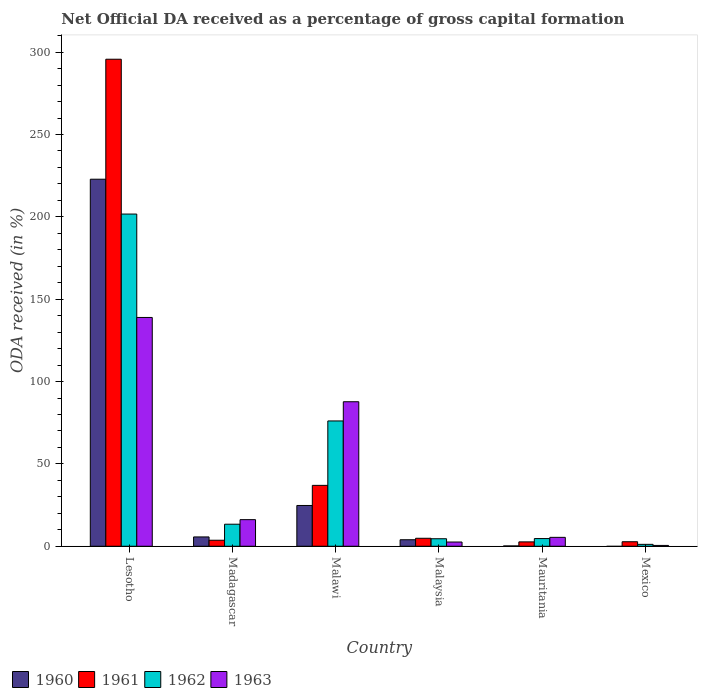How many groups of bars are there?
Ensure brevity in your answer.  6. Are the number of bars on each tick of the X-axis equal?
Your response must be concise. No. How many bars are there on the 3rd tick from the right?
Provide a succinct answer. 4. What is the label of the 2nd group of bars from the left?
Make the answer very short. Madagascar. What is the net ODA received in 1962 in Malawi?
Give a very brief answer. 76.08. Across all countries, what is the maximum net ODA received in 1961?
Ensure brevity in your answer.  295.71. Across all countries, what is the minimum net ODA received in 1961?
Your answer should be compact. 2.65. In which country was the net ODA received in 1960 maximum?
Provide a succinct answer. Lesotho. What is the total net ODA received in 1962 in the graph?
Offer a very short reply. 301.54. What is the difference between the net ODA received in 1963 in Malawi and that in Mauritania?
Offer a terse response. 82.34. What is the difference between the net ODA received in 1963 in Mauritania and the net ODA received in 1961 in Malaysia?
Your answer should be very brief. 0.56. What is the average net ODA received in 1962 per country?
Offer a very short reply. 50.26. What is the difference between the net ODA received of/in 1960 and net ODA received of/in 1962 in Malawi?
Provide a short and direct response. -51.32. What is the ratio of the net ODA received in 1963 in Lesotho to that in Madagascar?
Give a very brief answer. 8.6. Is the net ODA received in 1963 in Malawi less than that in Mauritania?
Keep it short and to the point. No. Is the difference between the net ODA received in 1960 in Madagascar and Mauritania greater than the difference between the net ODA received in 1962 in Madagascar and Mauritania?
Provide a succinct answer. No. What is the difference between the highest and the second highest net ODA received in 1960?
Your response must be concise. 19.11. What is the difference between the highest and the lowest net ODA received in 1963?
Ensure brevity in your answer.  138.41. In how many countries, is the net ODA received in 1963 greater than the average net ODA received in 1963 taken over all countries?
Provide a succinct answer. 2. Is the sum of the net ODA received in 1962 in Malaysia and Mauritania greater than the maximum net ODA received in 1963 across all countries?
Provide a succinct answer. No. Is it the case that in every country, the sum of the net ODA received in 1960 and net ODA received in 1962 is greater than the sum of net ODA received in 1963 and net ODA received in 1961?
Your response must be concise. No. Is it the case that in every country, the sum of the net ODA received in 1960 and net ODA received in 1963 is greater than the net ODA received in 1961?
Give a very brief answer. No. How many bars are there?
Your answer should be compact. 23. What is the difference between two consecutive major ticks on the Y-axis?
Provide a short and direct response. 50. Does the graph contain any zero values?
Keep it short and to the point. Yes. Does the graph contain grids?
Your response must be concise. No. Where does the legend appear in the graph?
Your response must be concise. Bottom left. What is the title of the graph?
Your answer should be very brief. Net Official DA received as a percentage of gross capital formation. What is the label or title of the Y-axis?
Your response must be concise. ODA received (in %). What is the ODA received (in %) in 1960 in Lesotho?
Ensure brevity in your answer.  222.86. What is the ODA received (in %) in 1961 in Lesotho?
Ensure brevity in your answer.  295.71. What is the ODA received (in %) in 1962 in Lesotho?
Offer a terse response. 201.7. What is the ODA received (in %) of 1963 in Lesotho?
Ensure brevity in your answer.  138.92. What is the ODA received (in %) of 1960 in Madagascar?
Your answer should be very brief. 5.66. What is the ODA received (in %) in 1961 in Madagascar?
Your answer should be very brief. 3.65. What is the ODA received (in %) in 1962 in Madagascar?
Give a very brief answer. 13.38. What is the ODA received (in %) in 1963 in Madagascar?
Give a very brief answer. 16.15. What is the ODA received (in %) of 1960 in Malawi?
Provide a succinct answer. 24.76. What is the ODA received (in %) of 1961 in Malawi?
Offer a very short reply. 36.97. What is the ODA received (in %) of 1962 in Malawi?
Your response must be concise. 76.08. What is the ODA received (in %) of 1963 in Malawi?
Offer a terse response. 87.74. What is the ODA received (in %) in 1960 in Malaysia?
Your answer should be very brief. 3.95. What is the ODA received (in %) in 1961 in Malaysia?
Make the answer very short. 4.84. What is the ODA received (in %) in 1962 in Malaysia?
Provide a succinct answer. 4.56. What is the ODA received (in %) of 1963 in Malaysia?
Your answer should be compact. 2.57. What is the ODA received (in %) in 1960 in Mauritania?
Provide a succinct answer. 0.19. What is the ODA received (in %) in 1961 in Mauritania?
Your response must be concise. 2.65. What is the ODA received (in %) of 1962 in Mauritania?
Your answer should be compact. 4.66. What is the ODA received (in %) of 1963 in Mauritania?
Offer a terse response. 5.4. What is the ODA received (in %) of 1961 in Mexico?
Give a very brief answer. 2.74. What is the ODA received (in %) in 1962 in Mexico?
Give a very brief answer. 1.16. What is the ODA received (in %) in 1963 in Mexico?
Make the answer very short. 0.5. Across all countries, what is the maximum ODA received (in %) of 1960?
Make the answer very short. 222.86. Across all countries, what is the maximum ODA received (in %) of 1961?
Ensure brevity in your answer.  295.71. Across all countries, what is the maximum ODA received (in %) in 1962?
Make the answer very short. 201.7. Across all countries, what is the maximum ODA received (in %) of 1963?
Provide a short and direct response. 138.92. Across all countries, what is the minimum ODA received (in %) of 1960?
Your response must be concise. 0. Across all countries, what is the minimum ODA received (in %) of 1961?
Your response must be concise. 2.65. Across all countries, what is the minimum ODA received (in %) in 1962?
Make the answer very short. 1.16. Across all countries, what is the minimum ODA received (in %) of 1963?
Your answer should be very brief. 0.5. What is the total ODA received (in %) of 1960 in the graph?
Give a very brief answer. 257.42. What is the total ODA received (in %) in 1961 in the graph?
Provide a short and direct response. 346.57. What is the total ODA received (in %) in 1962 in the graph?
Ensure brevity in your answer.  301.54. What is the total ODA received (in %) of 1963 in the graph?
Give a very brief answer. 251.28. What is the difference between the ODA received (in %) in 1960 in Lesotho and that in Madagascar?
Your response must be concise. 217.2. What is the difference between the ODA received (in %) of 1961 in Lesotho and that in Madagascar?
Your response must be concise. 292.06. What is the difference between the ODA received (in %) of 1962 in Lesotho and that in Madagascar?
Ensure brevity in your answer.  188.32. What is the difference between the ODA received (in %) in 1963 in Lesotho and that in Madagascar?
Provide a short and direct response. 122.76. What is the difference between the ODA received (in %) of 1960 in Lesotho and that in Malawi?
Keep it short and to the point. 198.1. What is the difference between the ODA received (in %) of 1961 in Lesotho and that in Malawi?
Make the answer very short. 258.74. What is the difference between the ODA received (in %) of 1962 in Lesotho and that in Malawi?
Your answer should be very brief. 125.62. What is the difference between the ODA received (in %) in 1963 in Lesotho and that in Malawi?
Give a very brief answer. 51.18. What is the difference between the ODA received (in %) of 1960 in Lesotho and that in Malaysia?
Offer a terse response. 218.91. What is the difference between the ODA received (in %) of 1961 in Lesotho and that in Malaysia?
Your response must be concise. 290.87. What is the difference between the ODA received (in %) in 1962 in Lesotho and that in Malaysia?
Keep it short and to the point. 197.14. What is the difference between the ODA received (in %) in 1963 in Lesotho and that in Malaysia?
Provide a short and direct response. 136.35. What is the difference between the ODA received (in %) of 1960 in Lesotho and that in Mauritania?
Your answer should be very brief. 222.67. What is the difference between the ODA received (in %) of 1961 in Lesotho and that in Mauritania?
Your answer should be compact. 293.07. What is the difference between the ODA received (in %) of 1962 in Lesotho and that in Mauritania?
Make the answer very short. 197.04. What is the difference between the ODA received (in %) of 1963 in Lesotho and that in Mauritania?
Your answer should be very brief. 133.51. What is the difference between the ODA received (in %) of 1961 in Lesotho and that in Mexico?
Your response must be concise. 292.98. What is the difference between the ODA received (in %) of 1962 in Lesotho and that in Mexico?
Your answer should be compact. 200.54. What is the difference between the ODA received (in %) in 1963 in Lesotho and that in Mexico?
Ensure brevity in your answer.  138.41. What is the difference between the ODA received (in %) in 1960 in Madagascar and that in Malawi?
Your answer should be compact. -19.11. What is the difference between the ODA received (in %) of 1961 in Madagascar and that in Malawi?
Keep it short and to the point. -33.32. What is the difference between the ODA received (in %) in 1962 in Madagascar and that in Malawi?
Give a very brief answer. -62.7. What is the difference between the ODA received (in %) in 1963 in Madagascar and that in Malawi?
Keep it short and to the point. -71.59. What is the difference between the ODA received (in %) of 1960 in Madagascar and that in Malaysia?
Your answer should be compact. 1.7. What is the difference between the ODA received (in %) in 1961 in Madagascar and that in Malaysia?
Your response must be concise. -1.19. What is the difference between the ODA received (in %) of 1962 in Madagascar and that in Malaysia?
Your answer should be compact. 8.82. What is the difference between the ODA received (in %) in 1963 in Madagascar and that in Malaysia?
Your answer should be compact. 13.59. What is the difference between the ODA received (in %) of 1960 in Madagascar and that in Mauritania?
Your answer should be very brief. 5.46. What is the difference between the ODA received (in %) of 1962 in Madagascar and that in Mauritania?
Provide a short and direct response. 8.72. What is the difference between the ODA received (in %) of 1963 in Madagascar and that in Mauritania?
Give a very brief answer. 10.75. What is the difference between the ODA received (in %) in 1962 in Madagascar and that in Mexico?
Keep it short and to the point. 12.22. What is the difference between the ODA received (in %) of 1963 in Madagascar and that in Mexico?
Keep it short and to the point. 15.65. What is the difference between the ODA received (in %) of 1960 in Malawi and that in Malaysia?
Your answer should be compact. 20.81. What is the difference between the ODA received (in %) of 1961 in Malawi and that in Malaysia?
Provide a short and direct response. 32.13. What is the difference between the ODA received (in %) in 1962 in Malawi and that in Malaysia?
Your answer should be very brief. 71.52. What is the difference between the ODA received (in %) of 1963 in Malawi and that in Malaysia?
Your answer should be compact. 85.17. What is the difference between the ODA received (in %) in 1960 in Malawi and that in Mauritania?
Your answer should be compact. 24.57. What is the difference between the ODA received (in %) in 1961 in Malawi and that in Mauritania?
Make the answer very short. 34.32. What is the difference between the ODA received (in %) in 1962 in Malawi and that in Mauritania?
Your response must be concise. 71.42. What is the difference between the ODA received (in %) of 1963 in Malawi and that in Mauritania?
Provide a succinct answer. 82.34. What is the difference between the ODA received (in %) of 1961 in Malawi and that in Mexico?
Provide a succinct answer. 34.23. What is the difference between the ODA received (in %) in 1962 in Malawi and that in Mexico?
Your answer should be compact. 74.92. What is the difference between the ODA received (in %) of 1963 in Malawi and that in Mexico?
Your answer should be compact. 87.24. What is the difference between the ODA received (in %) of 1960 in Malaysia and that in Mauritania?
Make the answer very short. 3.76. What is the difference between the ODA received (in %) of 1961 in Malaysia and that in Mauritania?
Make the answer very short. 2.2. What is the difference between the ODA received (in %) in 1962 in Malaysia and that in Mauritania?
Ensure brevity in your answer.  -0.1. What is the difference between the ODA received (in %) of 1963 in Malaysia and that in Mauritania?
Offer a very short reply. -2.83. What is the difference between the ODA received (in %) of 1961 in Malaysia and that in Mexico?
Provide a succinct answer. 2.11. What is the difference between the ODA received (in %) of 1962 in Malaysia and that in Mexico?
Offer a terse response. 3.4. What is the difference between the ODA received (in %) of 1963 in Malaysia and that in Mexico?
Offer a very short reply. 2.07. What is the difference between the ODA received (in %) in 1961 in Mauritania and that in Mexico?
Keep it short and to the point. -0.09. What is the difference between the ODA received (in %) of 1962 in Mauritania and that in Mexico?
Your response must be concise. 3.51. What is the difference between the ODA received (in %) of 1963 in Mauritania and that in Mexico?
Offer a terse response. 4.9. What is the difference between the ODA received (in %) in 1960 in Lesotho and the ODA received (in %) in 1961 in Madagascar?
Ensure brevity in your answer.  219.21. What is the difference between the ODA received (in %) in 1960 in Lesotho and the ODA received (in %) in 1962 in Madagascar?
Keep it short and to the point. 209.48. What is the difference between the ODA received (in %) in 1960 in Lesotho and the ODA received (in %) in 1963 in Madagascar?
Offer a very short reply. 206.7. What is the difference between the ODA received (in %) in 1961 in Lesotho and the ODA received (in %) in 1962 in Madagascar?
Your answer should be compact. 282.33. What is the difference between the ODA received (in %) in 1961 in Lesotho and the ODA received (in %) in 1963 in Madagascar?
Your answer should be very brief. 279.56. What is the difference between the ODA received (in %) of 1962 in Lesotho and the ODA received (in %) of 1963 in Madagascar?
Give a very brief answer. 185.55. What is the difference between the ODA received (in %) in 1960 in Lesotho and the ODA received (in %) in 1961 in Malawi?
Provide a short and direct response. 185.89. What is the difference between the ODA received (in %) of 1960 in Lesotho and the ODA received (in %) of 1962 in Malawi?
Make the answer very short. 146.78. What is the difference between the ODA received (in %) of 1960 in Lesotho and the ODA received (in %) of 1963 in Malawi?
Ensure brevity in your answer.  135.12. What is the difference between the ODA received (in %) of 1961 in Lesotho and the ODA received (in %) of 1962 in Malawi?
Give a very brief answer. 219.63. What is the difference between the ODA received (in %) of 1961 in Lesotho and the ODA received (in %) of 1963 in Malawi?
Your answer should be compact. 207.97. What is the difference between the ODA received (in %) of 1962 in Lesotho and the ODA received (in %) of 1963 in Malawi?
Ensure brevity in your answer.  113.96. What is the difference between the ODA received (in %) of 1960 in Lesotho and the ODA received (in %) of 1961 in Malaysia?
Provide a short and direct response. 218.01. What is the difference between the ODA received (in %) of 1960 in Lesotho and the ODA received (in %) of 1962 in Malaysia?
Ensure brevity in your answer.  218.3. What is the difference between the ODA received (in %) in 1960 in Lesotho and the ODA received (in %) in 1963 in Malaysia?
Provide a succinct answer. 220.29. What is the difference between the ODA received (in %) of 1961 in Lesotho and the ODA received (in %) of 1962 in Malaysia?
Offer a terse response. 291.15. What is the difference between the ODA received (in %) in 1961 in Lesotho and the ODA received (in %) in 1963 in Malaysia?
Your answer should be very brief. 293.15. What is the difference between the ODA received (in %) of 1962 in Lesotho and the ODA received (in %) of 1963 in Malaysia?
Provide a short and direct response. 199.13. What is the difference between the ODA received (in %) of 1960 in Lesotho and the ODA received (in %) of 1961 in Mauritania?
Provide a succinct answer. 220.21. What is the difference between the ODA received (in %) in 1960 in Lesotho and the ODA received (in %) in 1962 in Mauritania?
Provide a short and direct response. 218.19. What is the difference between the ODA received (in %) in 1960 in Lesotho and the ODA received (in %) in 1963 in Mauritania?
Your answer should be very brief. 217.45. What is the difference between the ODA received (in %) of 1961 in Lesotho and the ODA received (in %) of 1962 in Mauritania?
Give a very brief answer. 291.05. What is the difference between the ODA received (in %) of 1961 in Lesotho and the ODA received (in %) of 1963 in Mauritania?
Ensure brevity in your answer.  290.31. What is the difference between the ODA received (in %) in 1962 in Lesotho and the ODA received (in %) in 1963 in Mauritania?
Provide a succinct answer. 196.3. What is the difference between the ODA received (in %) in 1960 in Lesotho and the ODA received (in %) in 1961 in Mexico?
Your response must be concise. 220.12. What is the difference between the ODA received (in %) in 1960 in Lesotho and the ODA received (in %) in 1962 in Mexico?
Your answer should be compact. 221.7. What is the difference between the ODA received (in %) of 1960 in Lesotho and the ODA received (in %) of 1963 in Mexico?
Make the answer very short. 222.36. What is the difference between the ODA received (in %) in 1961 in Lesotho and the ODA received (in %) in 1962 in Mexico?
Keep it short and to the point. 294.56. What is the difference between the ODA received (in %) in 1961 in Lesotho and the ODA received (in %) in 1963 in Mexico?
Give a very brief answer. 295.21. What is the difference between the ODA received (in %) of 1962 in Lesotho and the ODA received (in %) of 1963 in Mexico?
Ensure brevity in your answer.  201.2. What is the difference between the ODA received (in %) of 1960 in Madagascar and the ODA received (in %) of 1961 in Malawi?
Keep it short and to the point. -31.32. What is the difference between the ODA received (in %) in 1960 in Madagascar and the ODA received (in %) in 1962 in Malawi?
Provide a short and direct response. -70.43. What is the difference between the ODA received (in %) of 1960 in Madagascar and the ODA received (in %) of 1963 in Malawi?
Your answer should be compact. -82.08. What is the difference between the ODA received (in %) of 1961 in Madagascar and the ODA received (in %) of 1962 in Malawi?
Give a very brief answer. -72.43. What is the difference between the ODA received (in %) of 1961 in Madagascar and the ODA received (in %) of 1963 in Malawi?
Keep it short and to the point. -84.09. What is the difference between the ODA received (in %) of 1962 in Madagascar and the ODA received (in %) of 1963 in Malawi?
Your response must be concise. -74.36. What is the difference between the ODA received (in %) in 1960 in Madagascar and the ODA received (in %) in 1961 in Malaysia?
Offer a terse response. 0.81. What is the difference between the ODA received (in %) in 1960 in Madagascar and the ODA received (in %) in 1962 in Malaysia?
Provide a succinct answer. 1.09. What is the difference between the ODA received (in %) in 1960 in Madagascar and the ODA received (in %) in 1963 in Malaysia?
Keep it short and to the point. 3.09. What is the difference between the ODA received (in %) of 1961 in Madagascar and the ODA received (in %) of 1962 in Malaysia?
Ensure brevity in your answer.  -0.91. What is the difference between the ODA received (in %) of 1961 in Madagascar and the ODA received (in %) of 1963 in Malaysia?
Provide a short and direct response. 1.08. What is the difference between the ODA received (in %) of 1962 in Madagascar and the ODA received (in %) of 1963 in Malaysia?
Offer a terse response. 10.81. What is the difference between the ODA received (in %) in 1960 in Madagascar and the ODA received (in %) in 1961 in Mauritania?
Give a very brief answer. 3.01. What is the difference between the ODA received (in %) of 1960 in Madagascar and the ODA received (in %) of 1962 in Mauritania?
Offer a terse response. 0.99. What is the difference between the ODA received (in %) in 1960 in Madagascar and the ODA received (in %) in 1963 in Mauritania?
Ensure brevity in your answer.  0.25. What is the difference between the ODA received (in %) of 1961 in Madagascar and the ODA received (in %) of 1962 in Mauritania?
Offer a terse response. -1.01. What is the difference between the ODA received (in %) of 1961 in Madagascar and the ODA received (in %) of 1963 in Mauritania?
Your response must be concise. -1.75. What is the difference between the ODA received (in %) of 1962 in Madagascar and the ODA received (in %) of 1963 in Mauritania?
Offer a terse response. 7.98. What is the difference between the ODA received (in %) of 1960 in Madagascar and the ODA received (in %) of 1961 in Mexico?
Provide a short and direct response. 2.92. What is the difference between the ODA received (in %) in 1960 in Madagascar and the ODA received (in %) in 1962 in Mexico?
Provide a short and direct response. 4.5. What is the difference between the ODA received (in %) of 1960 in Madagascar and the ODA received (in %) of 1963 in Mexico?
Offer a terse response. 5.15. What is the difference between the ODA received (in %) in 1961 in Madagascar and the ODA received (in %) in 1962 in Mexico?
Offer a terse response. 2.49. What is the difference between the ODA received (in %) of 1961 in Madagascar and the ODA received (in %) of 1963 in Mexico?
Your response must be concise. 3.15. What is the difference between the ODA received (in %) of 1962 in Madagascar and the ODA received (in %) of 1963 in Mexico?
Make the answer very short. 12.88. What is the difference between the ODA received (in %) in 1960 in Malawi and the ODA received (in %) in 1961 in Malaysia?
Your answer should be very brief. 19.92. What is the difference between the ODA received (in %) in 1960 in Malawi and the ODA received (in %) in 1962 in Malaysia?
Make the answer very short. 20.2. What is the difference between the ODA received (in %) of 1960 in Malawi and the ODA received (in %) of 1963 in Malaysia?
Your response must be concise. 22.19. What is the difference between the ODA received (in %) of 1961 in Malawi and the ODA received (in %) of 1962 in Malaysia?
Keep it short and to the point. 32.41. What is the difference between the ODA received (in %) of 1961 in Malawi and the ODA received (in %) of 1963 in Malaysia?
Make the answer very short. 34.4. What is the difference between the ODA received (in %) in 1962 in Malawi and the ODA received (in %) in 1963 in Malaysia?
Provide a short and direct response. 73.51. What is the difference between the ODA received (in %) of 1960 in Malawi and the ODA received (in %) of 1961 in Mauritania?
Make the answer very short. 22.11. What is the difference between the ODA received (in %) of 1960 in Malawi and the ODA received (in %) of 1962 in Mauritania?
Provide a succinct answer. 20.1. What is the difference between the ODA received (in %) in 1960 in Malawi and the ODA received (in %) in 1963 in Mauritania?
Offer a very short reply. 19.36. What is the difference between the ODA received (in %) of 1961 in Malawi and the ODA received (in %) of 1962 in Mauritania?
Provide a short and direct response. 32.31. What is the difference between the ODA received (in %) in 1961 in Malawi and the ODA received (in %) in 1963 in Mauritania?
Your response must be concise. 31.57. What is the difference between the ODA received (in %) of 1962 in Malawi and the ODA received (in %) of 1963 in Mauritania?
Ensure brevity in your answer.  70.68. What is the difference between the ODA received (in %) of 1960 in Malawi and the ODA received (in %) of 1961 in Mexico?
Offer a very short reply. 22.02. What is the difference between the ODA received (in %) of 1960 in Malawi and the ODA received (in %) of 1962 in Mexico?
Provide a succinct answer. 23.6. What is the difference between the ODA received (in %) of 1960 in Malawi and the ODA received (in %) of 1963 in Mexico?
Offer a terse response. 24.26. What is the difference between the ODA received (in %) in 1961 in Malawi and the ODA received (in %) in 1962 in Mexico?
Make the answer very short. 35.82. What is the difference between the ODA received (in %) in 1961 in Malawi and the ODA received (in %) in 1963 in Mexico?
Offer a very short reply. 36.47. What is the difference between the ODA received (in %) of 1962 in Malawi and the ODA received (in %) of 1963 in Mexico?
Your answer should be compact. 75.58. What is the difference between the ODA received (in %) in 1960 in Malaysia and the ODA received (in %) in 1961 in Mauritania?
Your answer should be compact. 1.3. What is the difference between the ODA received (in %) of 1960 in Malaysia and the ODA received (in %) of 1962 in Mauritania?
Offer a very short reply. -0.71. What is the difference between the ODA received (in %) in 1960 in Malaysia and the ODA received (in %) in 1963 in Mauritania?
Your response must be concise. -1.45. What is the difference between the ODA received (in %) of 1961 in Malaysia and the ODA received (in %) of 1962 in Mauritania?
Your answer should be compact. 0.18. What is the difference between the ODA received (in %) in 1961 in Malaysia and the ODA received (in %) in 1963 in Mauritania?
Keep it short and to the point. -0.56. What is the difference between the ODA received (in %) of 1962 in Malaysia and the ODA received (in %) of 1963 in Mauritania?
Offer a very short reply. -0.84. What is the difference between the ODA received (in %) of 1960 in Malaysia and the ODA received (in %) of 1961 in Mexico?
Ensure brevity in your answer.  1.21. What is the difference between the ODA received (in %) in 1960 in Malaysia and the ODA received (in %) in 1962 in Mexico?
Make the answer very short. 2.79. What is the difference between the ODA received (in %) in 1960 in Malaysia and the ODA received (in %) in 1963 in Mexico?
Make the answer very short. 3.45. What is the difference between the ODA received (in %) in 1961 in Malaysia and the ODA received (in %) in 1962 in Mexico?
Provide a short and direct response. 3.69. What is the difference between the ODA received (in %) of 1961 in Malaysia and the ODA received (in %) of 1963 in Mexico?
Provide a succinct answer. 4.34. What is the difference between the ODA received (in %) of 1962 in Malaysia and the ODA received (in %) of 1963 in Mexico?
Your response must be concise. 4.06. What is the difference between the ODA received (in %) in 1960 in Mauritania and the ODA received (in %) in 1961 in Mexico?
Ensure brevity in your answer.  -2.55. What is the difference between the ODA received (in %) in 1960 in Mauritania and the ODA received (in %) in 1962 in Mexico?
Give a very brief answer. -0.97. What is the difference between the ODA received (in %) in 1960 in Mauritania and the ODA received (in %) in 1963 in Mexico?
Your response must be concise. -0.31. What is the difference between the ODA received (in %) in 1961 in Mauritania and the ODA received (in %) in 1962 in Mexico?
Give a very brief answer. 1.49. What is the difference between the ODA received (in %) in 1961 in Mauritania and the ODA received (in %) in 1963 in Mexico?
Ensure brevity in your answer.  2.15. What is the difference between the ODA received (in %) of 1962 in Mauritania and the ODA received (in %) of 1963 in Mexico?
Offer a terse response. 4.16. What is the average ODA received (in %) in 1960 per country?
Make the answer very short. 42.9. What is the average ODA received (in %) of 1961 per country?
Offer a terse response. 57.76. What is the average ODA received (in %) in 1962 per country?
Your response must be concise. 50.26. What is the average ODA received (in %) in 1963 per country?
Provide a short and direct response. 41.88. What is the difference between the ODA received (in %) of 1960 and ODA received (in %) of 1961 in Lesotho?
Your answer should be compact. -72.86. What is the difference between the ODA received (in %) of 1960 and ODA received (in %) of 1962 in Lesotho?
Your response must be concise. 21.16. What is the difference between the ODA received (in %) in 1960 and ODA received (in %) in 1963 in Lesotho?
Make the answer very short. 83.94. What is the difference between the ODA received (in %) of 1961 and ODA received (in %) of 1962 in Lesotho?
Your answer should be compact. 94.01. What is the difference between the ODA received (in %) in 1961 and ODA received (in %) in 1963 in Lesotho?
Keep it short and to the point. 156.8. What is the difference between the ODA received (in %) of 1962 and ODA received (in %) of 1963 in Lesotho?
Give a very brief answer. 62.78. What is the difference between the ODA received (in %) of 1960 and ODA received (in %) of 1961 in Madagascar?
Make the answer very short. 2. What is the difference between the ODA received (in %) in 1960 and ODA received (in %) in 1962 in Madagascar?
Your answer should be compact. -7.72. What is the difference between the ODA received (in %) in 1960 and ODA received (in %) in 1963 in Madagascar?
Ensure brevity in your answer.  -10.5. What is the difference between the ODA received (in %) in 1961 and ODA received (in %) in 1962 in Madagascar?
Provide a succinct answer. -9.73. What is the difference between the ODA received (in %) of 1961 and ODA received (in %) of 1963 in Madagascar?
Provide a succinct answer. -12.5. What is the difference between the ODA received (in %) of 1962 and ODA received (in %) of 1963 in Madagascar?
Ensure brevity in your answer.  -2.77. What is the difference between the ODA received (in %) in 1960 and ODA received (in %) in 1961 in Malawi?
Provide a succinct answer. -12.21. What is the difference between the ODA received (in %) of 1960 and ODA received (in %) of 1962 in Malawi?
Make the answer very short. -51.32. What is the difference between the ODA received (in %) in 1960 and ODA received (in %) in 1963 in Malawi?
Your response must be concise. -62.98. What is the difference between the ODA received (in %) of 1961 and ODA received (in %) of 1962 in Malawi?
Provide a short and direct response. -39.11. What is the difference between the ODA received (in %) of 1961 and ODA received (in %) of 1963 in Malawi?
Offer a terse response. -50.77. What is the difference between the ODA received (in %) of 1962 and ODA received (in %) of 1963 in Malawi?
Provide a short and direct response. -11.66. What is the difference between the ODA received (in %) of 1960 and ODA received (in %) of 1961 in Malaysia?
Keep it short and to the point. -0.89. What is the difference between the ODA received (in %) of 1960 and ODA received (in %) of 1962 in Malaysia?
Offer a terse response. -0.61. What is the difference between the ODA received (in %) in 1960 and ODA received (in %) in 1963 in Malaysia?
Your answer should be very brief. 1.38. What is the difference between the ODA received (in %) of 1961 and ODA received (in %) of 1962 in Malaysia?
Offer a terse response. 0.28. What is the difference between the ODA received (in %) in 1961 and ODA received (in %) in 1963 in Malaysia?
Ensure brevity in your answer.  2.28. What is the difference between the ODA received (in %) in 1962 and ODA received (in %) in 1963 in Malaysia?
Make the answer very short. 1.99. What is the difference between the ODA received (in %) in 1960 and ODA received (in %) in 1961 in Mauritania?
Give a very brief answer. -2.46. What is the difference between the ODA received (in %) in 1960 and ODA received (in %) in 1962 in Mauritania?
Provide a succinct answer. -4.47. What is the difference between the ODA received (in %) of 1960 and ODA received (in %) of 1963 in Mauritania?
Give a very brief answer. -5.21. What is the difference between the ODA received (in %) of 1961 and ODA received (in %) of 1962 in Mauritania?
Make the answer very short. -2.02. What is the difference between the ODA received (in %) in 1961 and ODA received (in %) in 1963 in Mauritania?
Your response must be concise. -2.75. What is the difference between the ODA received (in %) in 1962 and ODA received (in %) in 1963 in Mauritania?
Provide a succinct answer. -0.74. What is the difference between the ODA received (in %) of 1961 and ODA received (in %) of 1962 in Mexico?
Your response must be concise. 1.58. What is the difference between the ODA received (in %) in 1961 and ODA received (in %) in 1963 in Mexico?
Provide a short and direct response. 2.24. What is the difference between the ODA received (in %) of 1962 and ODA received (in %) of 1963 in Mexico?
Give a very brief answer. 0.66. What is the ratio of the ODA received (in %) of 1960 in Lesotho to that in Madagascar?
Offer a terse response. 39.4. What is the ratio of the ODA received (in %) of 1961 in Lesotho to that in Madagascar?
Ensure brevity in your answer.  80.97. What is the ratio of the ODA received (in %) in 1962 in Lesotho to that in Madagascar?
Make the answer very short. 15.07. What is the ratio of the ODA received (in %) of 1963 in Lesotho to that in Madagascar?
Give a very brief answer. 8.6. What is the ratio of the ODA received (in %) in 1960 in Lesotho to that in Malawi?
Provide a succinct answer. 9. What is the ratio of the ODA received (in %) of 1961 in Lesotho to that in Malawi?
Keep it short and to the point. 8. What is the ratio of the ODA received (in %) of 1962 in Lesotho to that in Malawi?
Ensure brevity in your answer.  2.65. What is the ratio of the ODA received (in %) of 1963 in Lesotho to that in Malawi?
Give a very brief answer. 1.58. What is the ratio of the ODA received (in %) of 1960 in Lesotho to that in Malaysia?
Keep it short and to the point. 56.41. What is the ratio of the ODA received (in %) of 1961 in Lesotho to that in Malaysia?
Offer a very short reply. 61.04. What is the ratio of the ODA received (in %) of 1962 in Lesotho to that in Malaysia?
Ensure brevity in your answer.  44.23. What is the ratio of the ODA received (in %) of 1963 in Lesotho to that in Malaysia?
Keep it short and to the point. 54.07. What is the ratio of the ODA received (in %) in 1960 in Lesotho to that in Mauritania?
Your answer should be compact. 1167.54. What is the ratio of the ODA received (in %) in 1961 in Lesotho to that in Mauritania?
Ensure brevity in your answer.  111.63. What is the ratio of the ODA received (in %) in 1962 in Lesotho to that in Mauritania?
Provide a succinct answer. 43.24. What is the ratio of the ODA received (in %) of 1963 in Lesotho to that in Mauritania?
Your answer should be compact. 25.71. What is the ratio of the ODA received (in %) in 1961 in Lesotho to that in Mexico?
Make the answer very short. 107.96. What is the ratio of the ODA received (in %) in 1962 in Lesotho to that in Mexico?
Provide a succinct answer. 174.32. What is the ratio of the ODA received (in %) of 1963 in Lesotho to that in Mexico?
Offer a terse response. 276.96. What is the ratio of the ODA received (in %) in 1960 in Madagascar to that in Malawi?
Offer a terse response. 0.23. What is the ratio of the ODA received (in %) of 1961 in Madagascar to that in Malawi?
Your response must be concise. 0.1. What is the ratio of the ODA received (in %) of 1962 in Madagascar to that in Malawi?
Make the answer very short. 0.18. What is the ratio of the ODA received (in %) of 1963 in Madagascar to that in Malawi?
Offer a terse response. 0.18. What is the ratio of the ODA received (in %) of 1960 in Madagascar to that in Malaysia?
Your response must be concise. 1.43. What is the ratio of the ODA received (in %) in 1961 in Madagascar to that in Malaysia?
Keep it short and to the point. 0.75. What is the ratio of the ODA received (in %) in 1962 in Madagascar to that in Malaysia?
Your response must be concise. 2.93. What is the ratio of the ODA received (in %) in 1963 in Madagascar to that in Malaysia?
Ensure brevity in your answer.  6.29. What is the ratio of the ODA received (in %) in 1960 in Madagascar to that in Mauritania?
Keep it short and to the point. 29.63. What is the ratio of the ODA received (in %) in 1961 in Madagascar to that in Mauritania?
Make the answer very short. 1.38. What is the ratio of the ODA received (in %) in 1962 in Madagascar to that in Mauritania?
Offer a very short reply. 2.87. What is the ratio of the ODA received (in %) of 1963 in Madagascar to that in Mauritania?
Ensure brevity in your answer.  2.99. What is the ratio of the ODA received (in %) in 1961 in Madagascar to that in Mexico?
Offer a very short reply. 1.33. What is the ratio of the ODA received (in %) in 1962 in Madagascar to that in Mexico?
Give a very brief answer. 11.56. What is the ratio of the ODA received (in %) of 1963 in Madagascar to that in Mexico?
Offer a terse response. 32.21. What is the ratio of the ODA received (in %) of 1960 in Malawi to that in Malaysia?
Your response must be concise. 6.27. What is the ratio of the ODA received (in %) in 1961 in Malawi to that in Malaysia?
Give a very brief answer. 7.63. What is the ratio of the ODA received (in %) in 1962 in Malawi to that in Malaysia?
Give a very brief answer. 16.68. What is the ratio of the ODA received (in %) of 1963 in Malawi to that in Malaysia?
Your answer should be compact. 34.15. What is the ratio of the ODA received (in %) in 1960 in Malawi to that in Mauritania?
Provide a short and direct response. 129.73. What is the ratio of the ODA received (in %) of 1961 in Malawi to that in Mauritania?
Your response must be concise. 13.96. What is the ratio of the ODA received (in %) of 1962 in Malawi to that in Mauritania?
Offer a terse response. 16.31. What is the ratio of the ODA received (in %) in 1963 in Malawi to that in Mauritania?
Ensure brevity in your answer.  16.24. What is the ratio of the ODA received (in %) of 1961 in Malawi to that in Mexico?
Your answer should be very brief. 13.5. What is the ratio of the ODA received (in %) in 1962 in Malawi to that in Mexico?
Your answer should be very brief. 65.75. What is the ratio of the ODA received (in %) of 1963 in Malawi to that in Mexico?
Provide a succinct answer. 174.93. What is the ratio of the ODA received (in %) of 1960 in Malaysia to that in Mauritania?
Your response must be concise. 20.7. What is the ratio of the ODA received (in %) in 1961 in Malaysia to that in Mauritania?
Your answer should be very brief. 1.83. What is the ratio of the ODA received (in %) in 1962 in Malaysia to that in Mauritania?
Make the answer very short. 0.98. What is the ratio of the ODA received (in %) in 1963 in Malaysia to that in Mauritania?
Your answer should be compact. 0.48. What is the ratio of the ODA received (in %) in 1961 in Malaysia to that in Mexico?
Provide a succinct answer. 1.77. What is the ratio of the ODA received (in %) in 1962 in Malaysia to that in Mexico?
Your answer should be very brief. 3.94. What is the ratio of the ODA received (in %) of 1963 in Malaysia to that in Mexico?
Offer a very short reply. 5.12. What is the ratio of the ODA received (in %) in 1961 in Mauritania to that in Mexico?
Offer a very short reply. 0.97. What is the ratio of the ODA received (in %) in 1962 in Mauritania to that in Mexico?
Provide a short and direct response. 4.03. What is the ratio of the ODA received (in %) of 1963 in Mauritania to that in Mexico?
Provide a short and direct response. 10.77. What is the difference between the highest and the second highest ODA received (in %) of 1960?
Offer a terse response. 198.1. What is the difference between the highest and the second highest ODA received (in %) in 1961?
Keep it short and to the point. 258.74. What is the difference between the highest and the second highest ODA received (in %) in 1962?
Provide a short and direct response. 125.62. What is the difference between the highest and the second highest ODA received (in %) of 1963?
Provide a short and direct response. 51.18. What is the difference between the highest and the lowest ODA received (in %) of 1960?
Your answer should be compact. 222.86. What is the difference between the highest and the lowest ODA received (in %) of 1961?
Offer a very short reply. 293.07. What is the difference between the highest and the lowest ODA received (in %) in 1962?
Your response must be concise. 200.54. What is the difference between the highest and the lowest ODA received (in %) of 1963?
Your answer should be compact. 138.41. 